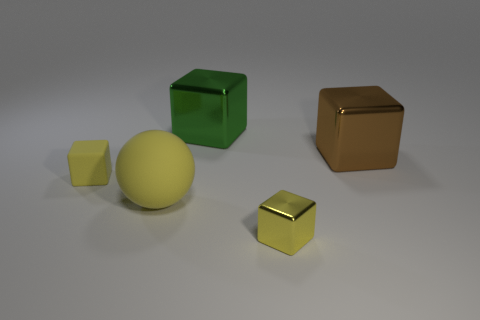Subtract all purple cubes. Subtract all blue cylinders. How many cubes are left? 4 Add 3 purple shiny cylinders. How many objects exist? 8 Subtract all cubes. How many objects are left? 1 Subtract 0 gray cylinders. How many objects are left? 5 Subtract all small shiny things. Subtract all yellow things. How many objects are left? 1 Add 4 yellow objects. How many yellow objects are left? 7 Add 1 brown metal cubes. How many brown metal cubes exist? 2 